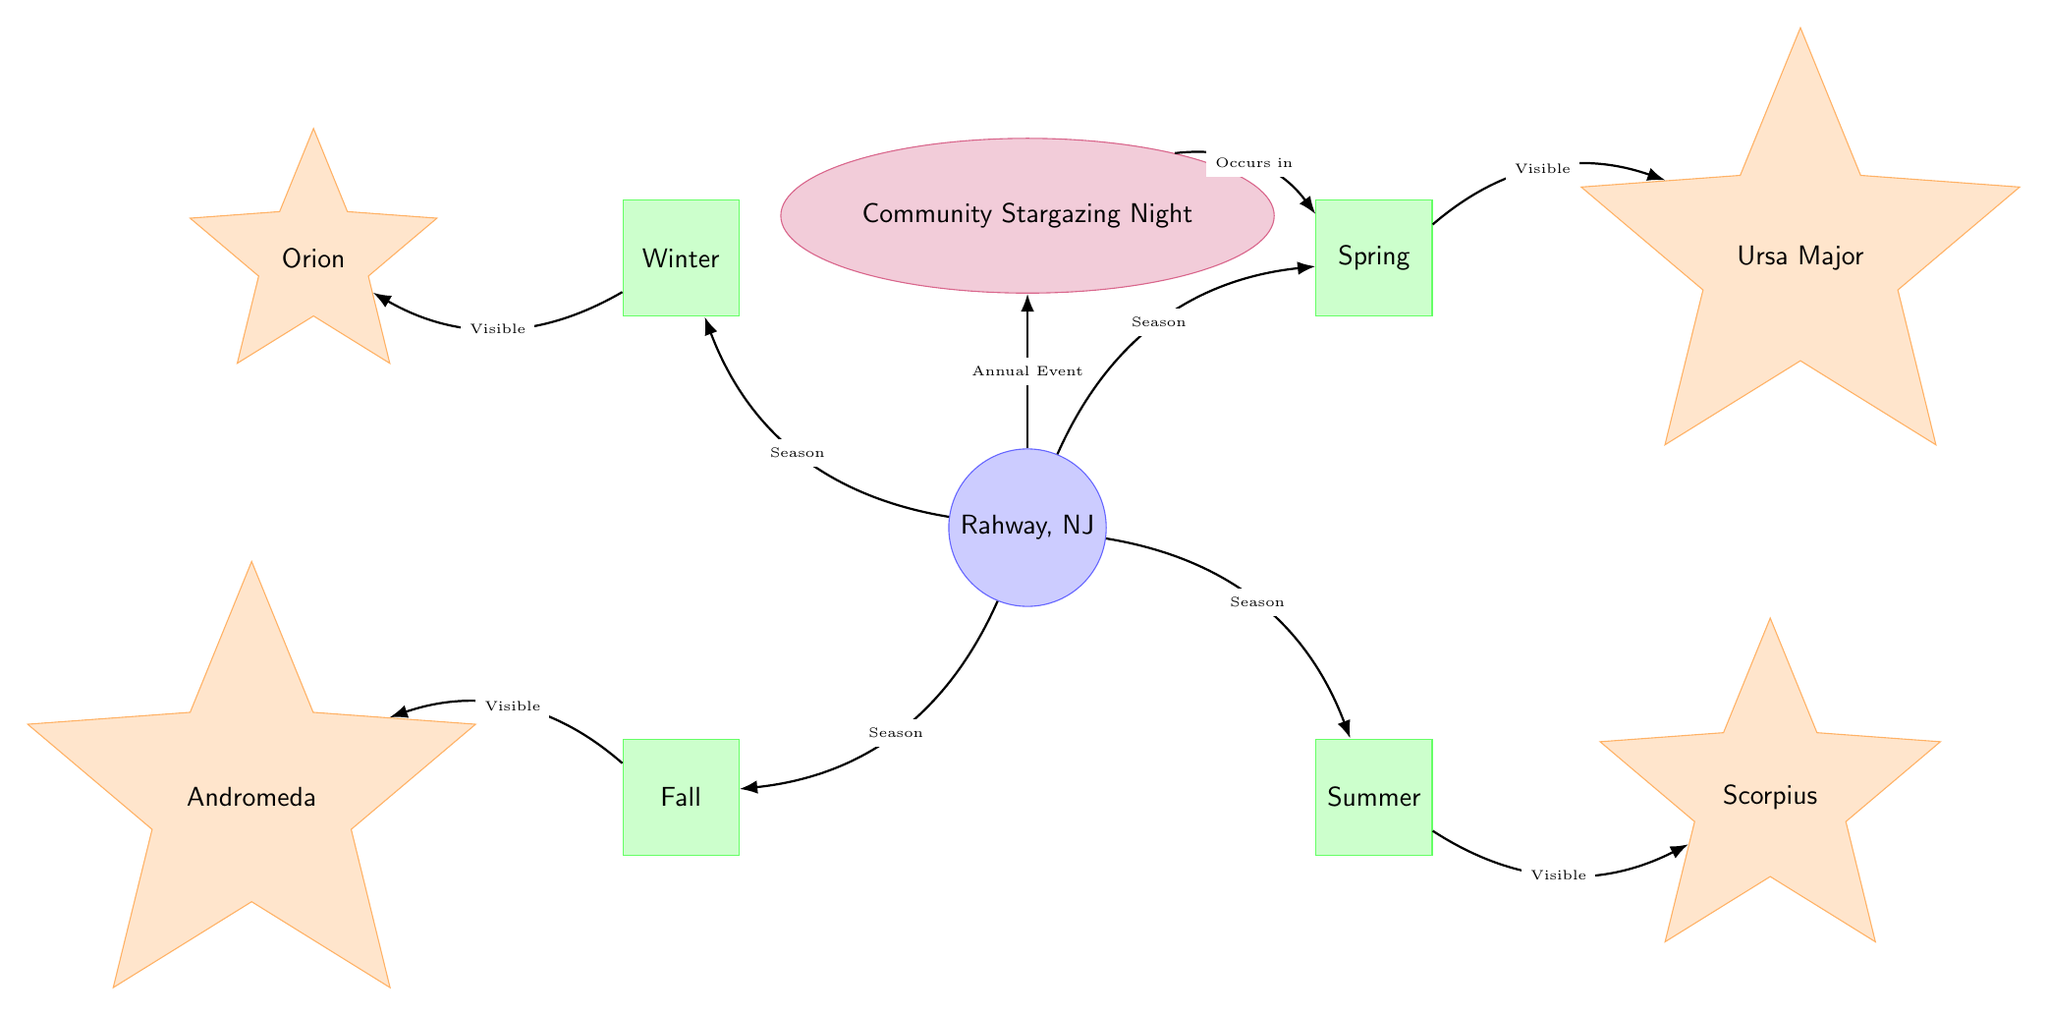What constellations are visible in winter? The diagram indicates that the winter season is associated with the Orion constellation. It is specifically shown with a direct edge linking winter to Orion, indicating visibility.
Answer: Orion Which season corresponds to Ursa Major's visibility? According to the diagram, the spring season has a direct connection to the Ursa Major constellation, signifying that it is visible during this time.
Answer: Spring How many constellations are shown in the diagram? By counting the distinct star-shaped nodes in the diagram, we see Orion, Ursa Major, Scorpius, and Andromeda, which totals four constellations present in the diagram.
Answer: 4 What is the annual event highlighted in the diagram? The diagram features a clearly labeled node that specifies a community event called "Community Stargazing Night," indicating its significance as an annual event in the diagram.
Answer: Community Stargazing Night During which season does the Community Stargazing Night occur? The diagram illustrates that the Community Stargazing Night is connected to the spring season, indicating when this event takes place.
Answer: Spring What constellations can be seen in the fall? The diagram indicates that Andromeda is the constellation that is specifically visible during the fall season, which is shown with a direct link from fall to Andromeda.
Answer: Andromeda Which seasonal constellation is visible in summer? The diagram provides an edge linking the summer season to the Scorpius constellation, demonstrating that it can be observed during this specific time.
Answer: Scorpius What relationship exists between Rahway and the seasons? The diagram shows that each season (winter, spring, summer, fall) has a direct connection to Rahway, indicating that they all relate to the visibility of constellations in this location.
Answer: Seasons How many edges connect Rahway to constellations? By examining the edges leading from Rahway to the four seasons, and then further to the constellations, we can count a total of four direct connections for visibility, each linking to a specific constellation.
Answer: 4 